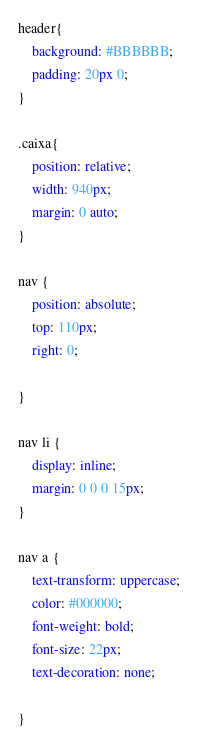<code> <loc_0><loc_0><loc_500><loc_500><_CSS_>header{
    background: #BBBBBB;
    padding: 20px 0;
}

.caixa{
    position: relative;
    width: 940px;
    margin: 0 auto;
}

nav {
    position: absolute;
    top: 110px;
    right: 0;

}

nav li {
    display: inline;
    margin: 0 0 0 15px;
}

nav a {
    text-transform: uppercase;
    color: #000000;
    font-weight: bold;
    font-size: 22px;
    text-decoration: none;

}</code> 